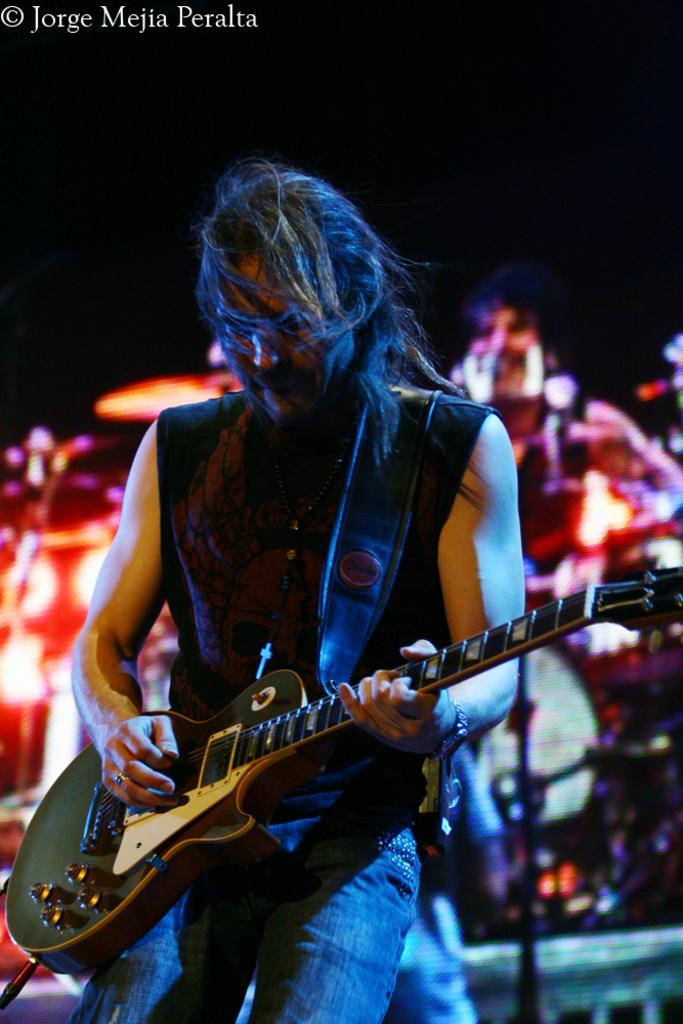What is the main subject of the picture? The main subject of the picture is a person. What is the person holding in the image? The person is holding a guitar. What is the person doing with the guitar? The person is playing the guitar. Can you describe the people in the background of the image? There are people sitting in the background of the image. What type of jeans is the person wearing in the image? There is no information about the person's clothing in the image, so we cannot determine if they are wearing jeans or any other type of clothing. 